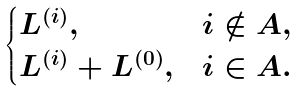Convert formula to latex. <formula><loc_0><loc_0><loc_500><loc_500>\begin{cases} L ^ { ( i ) } , & i \notin A , \\ L ^ { ( i ) } + L ^ { ( 0 ) } , & i \in A . \end{cases}</formula> 